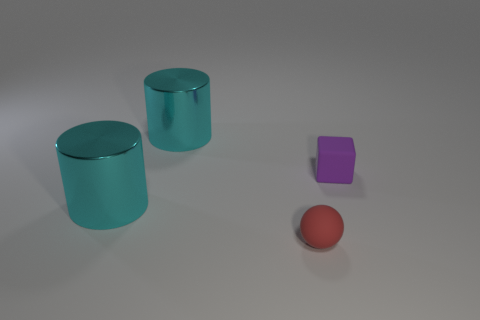Is the material of the object right of the red matte object the same as the tiny thing left of the small matte block?
Your response must be concise. Yes. There is a thing that is in front of the small purple object and to the left of the red matte ball; what is its material?
Keep it short and to the point. Metal. What is the material of the object that is to the right of the tiny matte thing on the left side of the small matte thing that is behind the small red sphere?
Your response must be concise. Rubber. How many other things are the same size as the matte cube?
Keep it short and to the point. 1. There is a big metallic cylinder that is behind the matte object right of the red rubber thing; what number of cyan things are in front of it?
Give a very brief answer. 1. What is the material of the cylinder on the right side of the cyan shiny cylinder in front of the purple rubber cube?
Your answer should be very brief. Metal. Are there any other small red matte things of the same shape as the red object?
Your response must be concise. No. What is the color of the rubber sphere that is the same size as the cube?
Your answer should be very brief. Red. What number of objects are cyan shiny cylinders that are in front of the purple matte cube or things that are to the right of the small red object?
Keep it short and to the point. 2. How many things are big gray objects or red spheres?
Your answer should be compact. 1. 